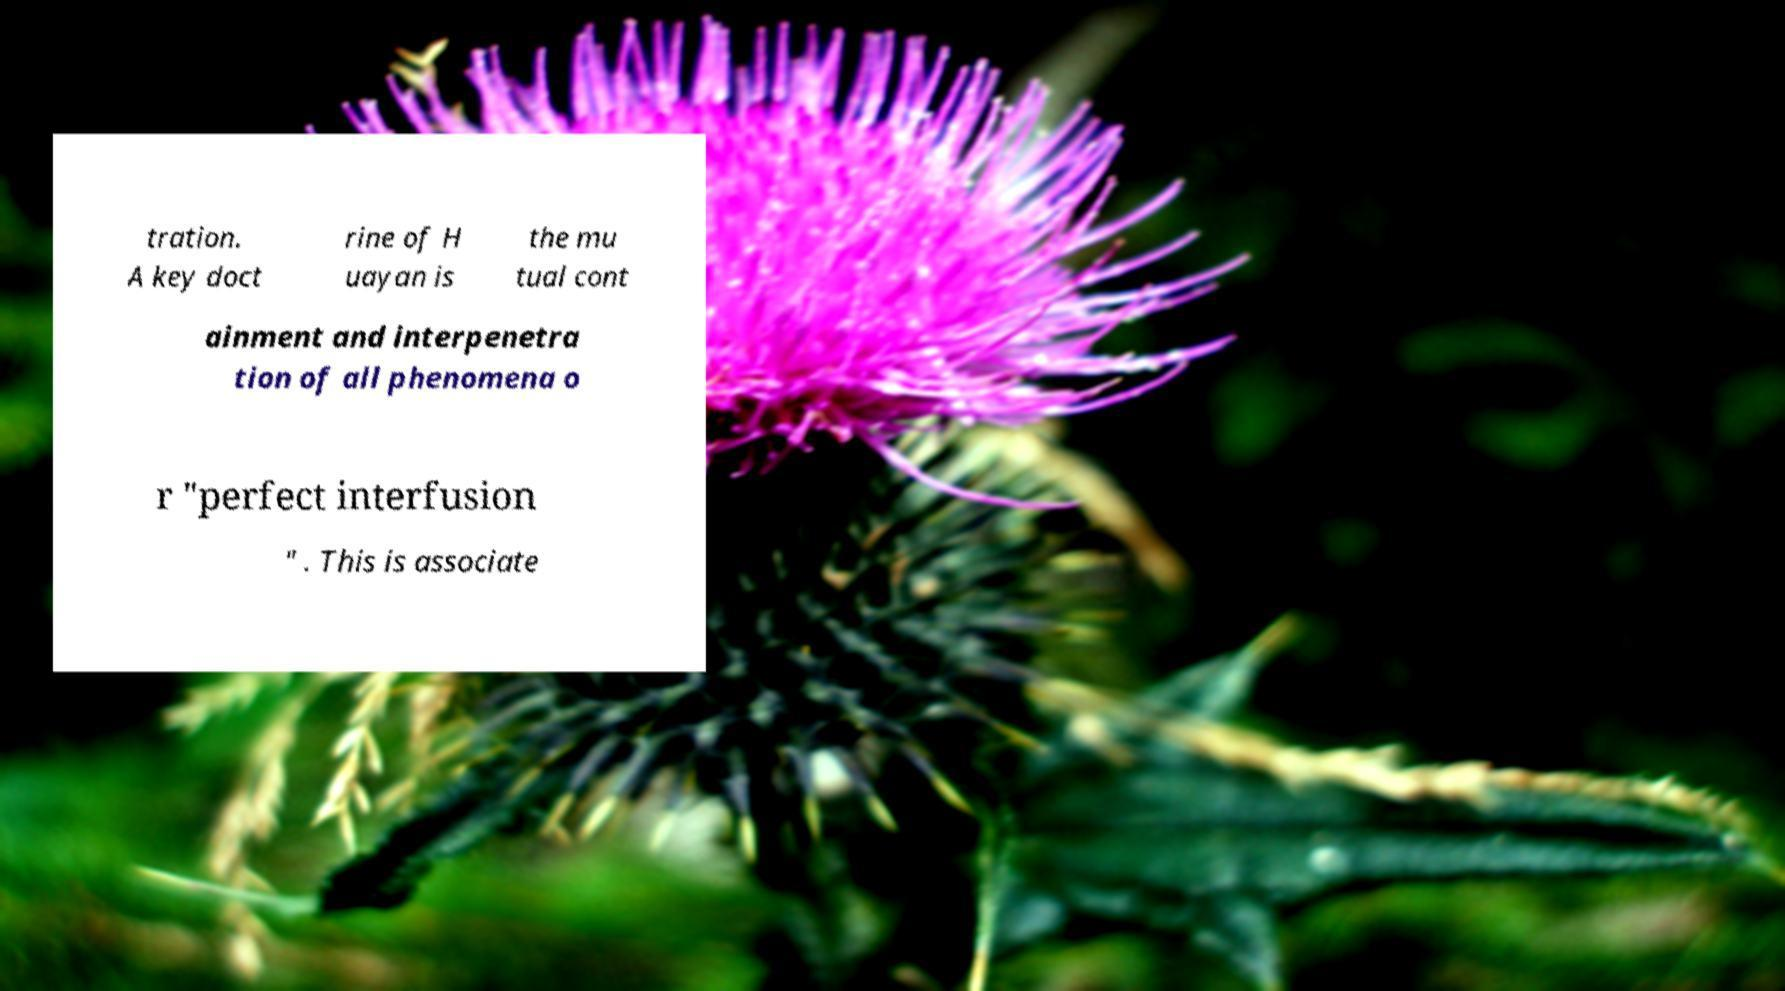For documentation purposes, I need the text within this image transcribed. Could you provide that? tration. A key doct rine of H uayan is the mu tual cont ainment and interpenetra tion of all phenomena o r "perfect interfusion " . This is associate 